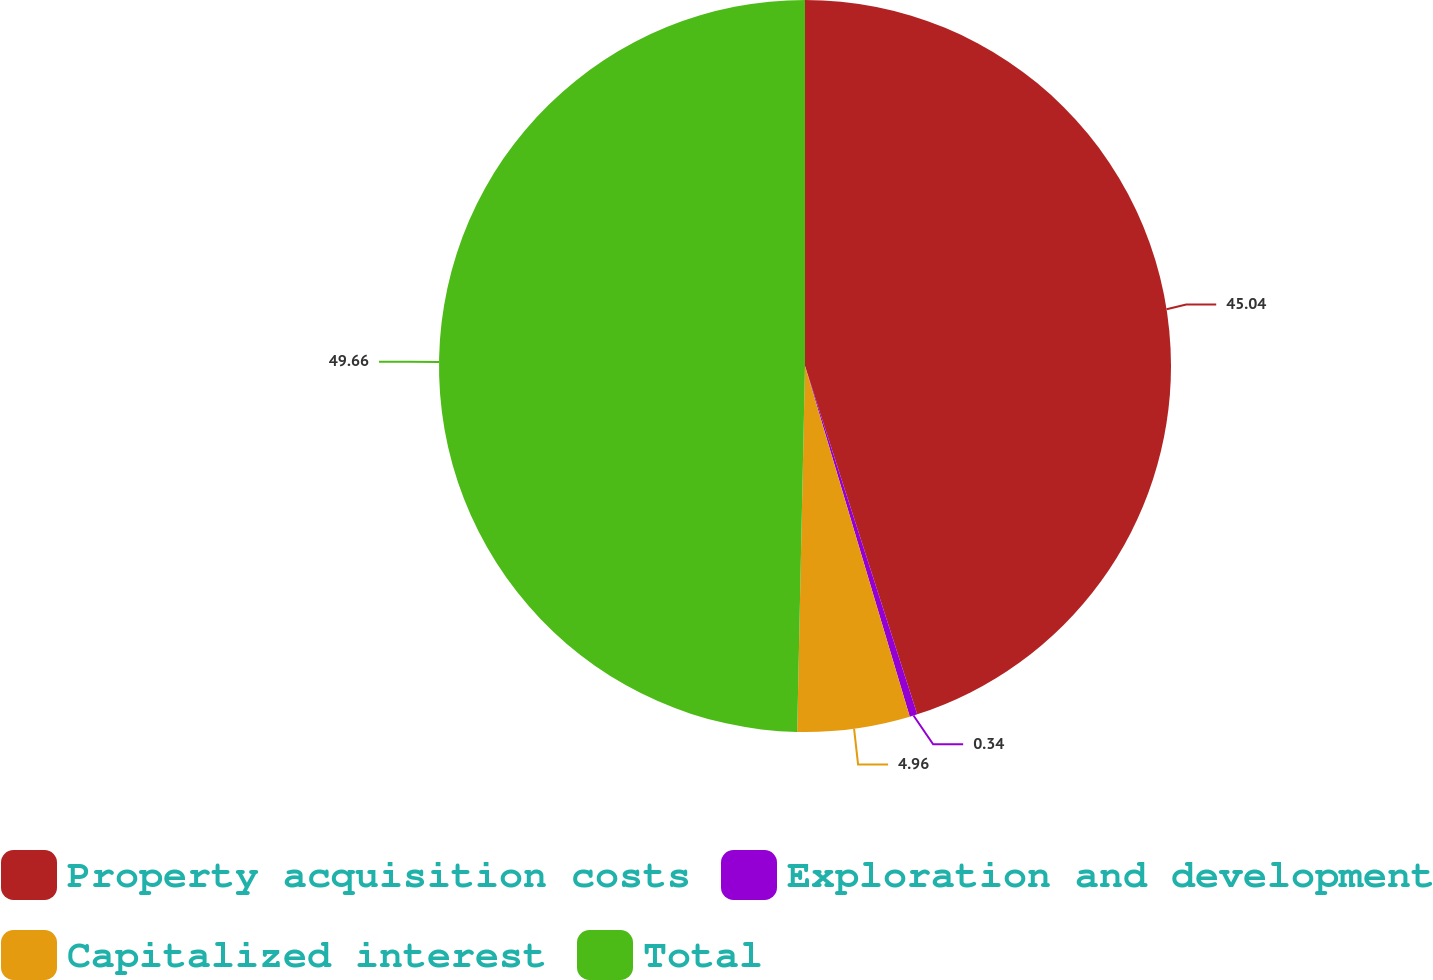Convert chart to OTSL. <chart><loc_0><loc_0><loc_500><loc_500><pie_chart><fcel>Property acquisition costs<fcel>Exploration and development<fcel>Capitalized interest<fcel>Total<nl><fcel>45.04%<fcel>0.34%<fcel>4.96%<fcel>49.66%<nl></chart> 